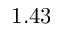Convert formula to latex. <formula><loc_0><loc_0><loc_500><loc_500>1 . 4 3</formula> 